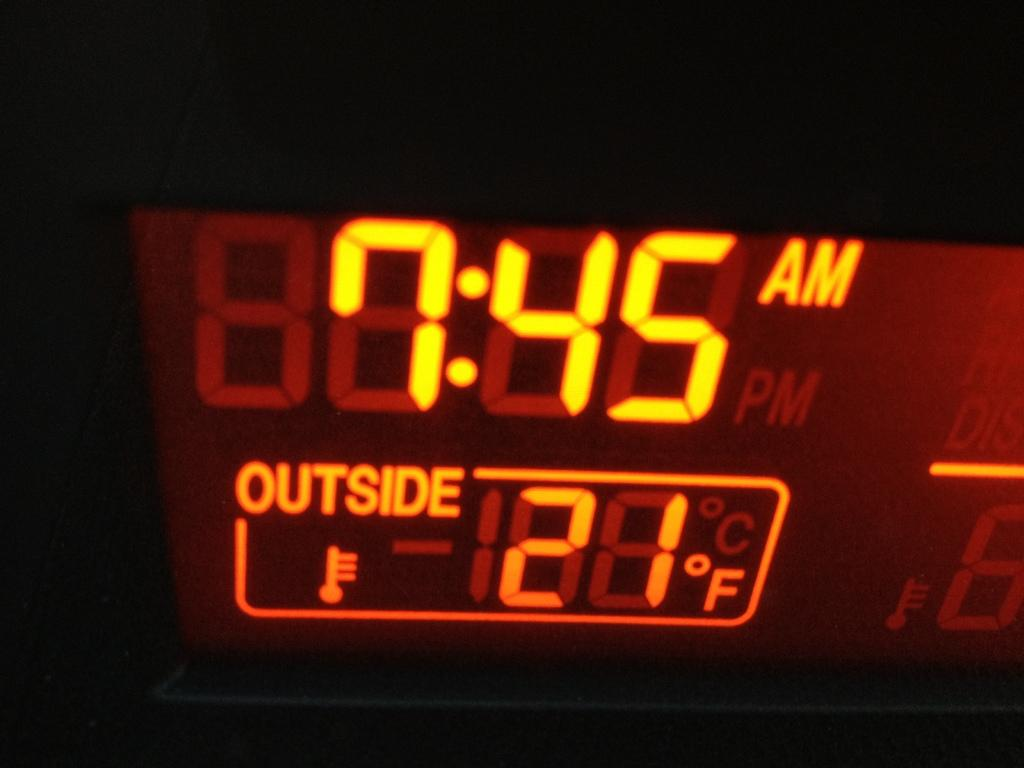<image>
Share a concise interpretation of the image provided. A digital displays the temp at 21 F and the time of 7:45 AM. 